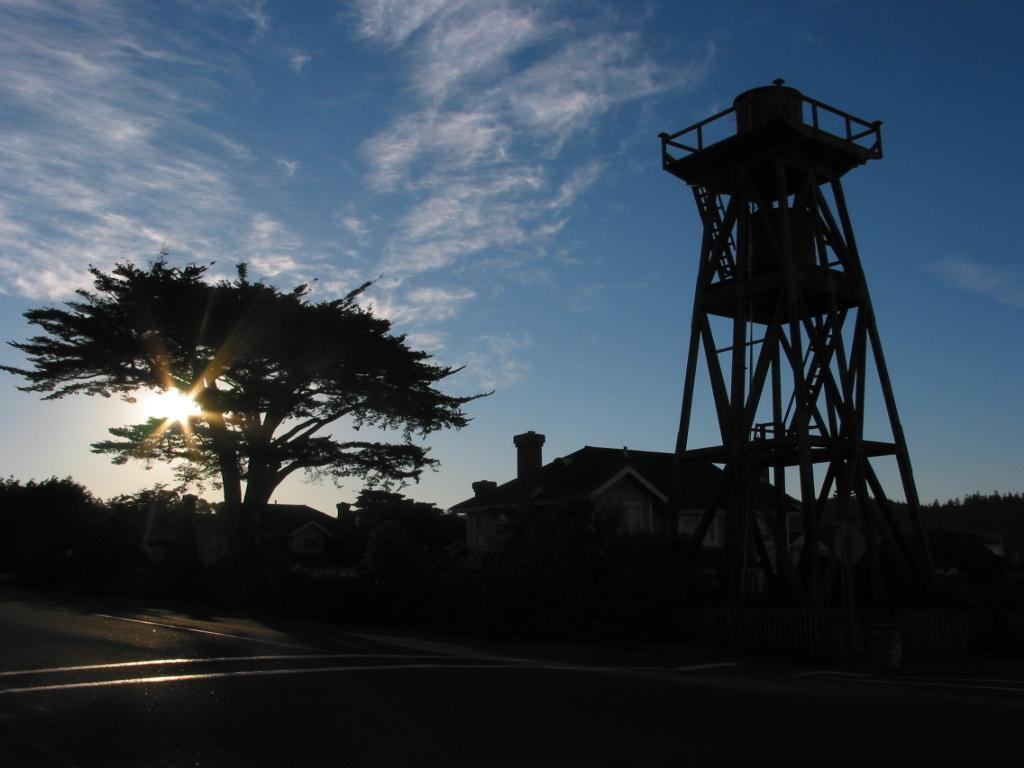What type of vegetation can be seen in the image? There are trees in the image. What type of structure is present in the image? There is a house and an observation tower in the image. What can be used for transportation in the image? There is a road visible in the image. What is the condition of the sky in the image? The sky is cloudy in the image. How many chickens are crossing the road in the image? There are no chickens present in the image. What type of ray is visible in the image? There is no ray visible in the image. 